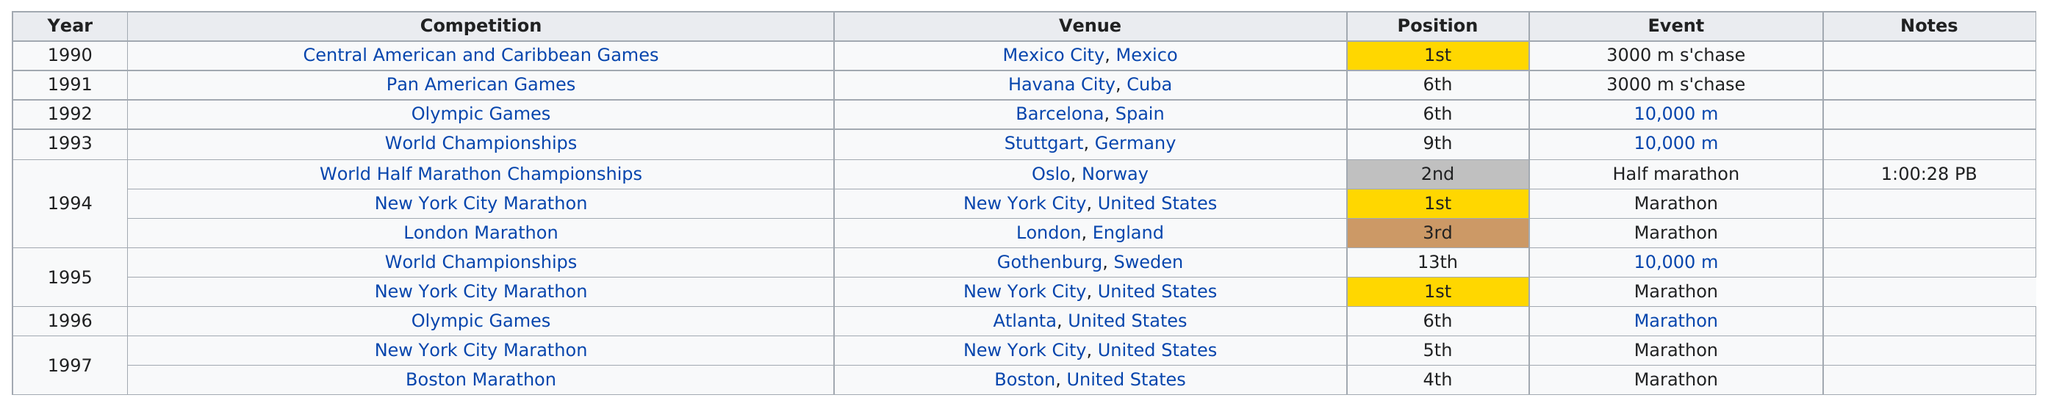Give some essential details in this illustration. Silva placed fifth in the competition after the Olympic Games in 1996. German Silva has placed in the top 3 in 5 total international races. Silva placed first in the 3000m s'chase at the Central American and Caribbean Games in 1990. The New York City Marathon was the competition that took place before the Olympic Games in Atlanta, United States. German Silva placed fourth in an international race after 1995, which was the highest achievement he made in this category of events. 